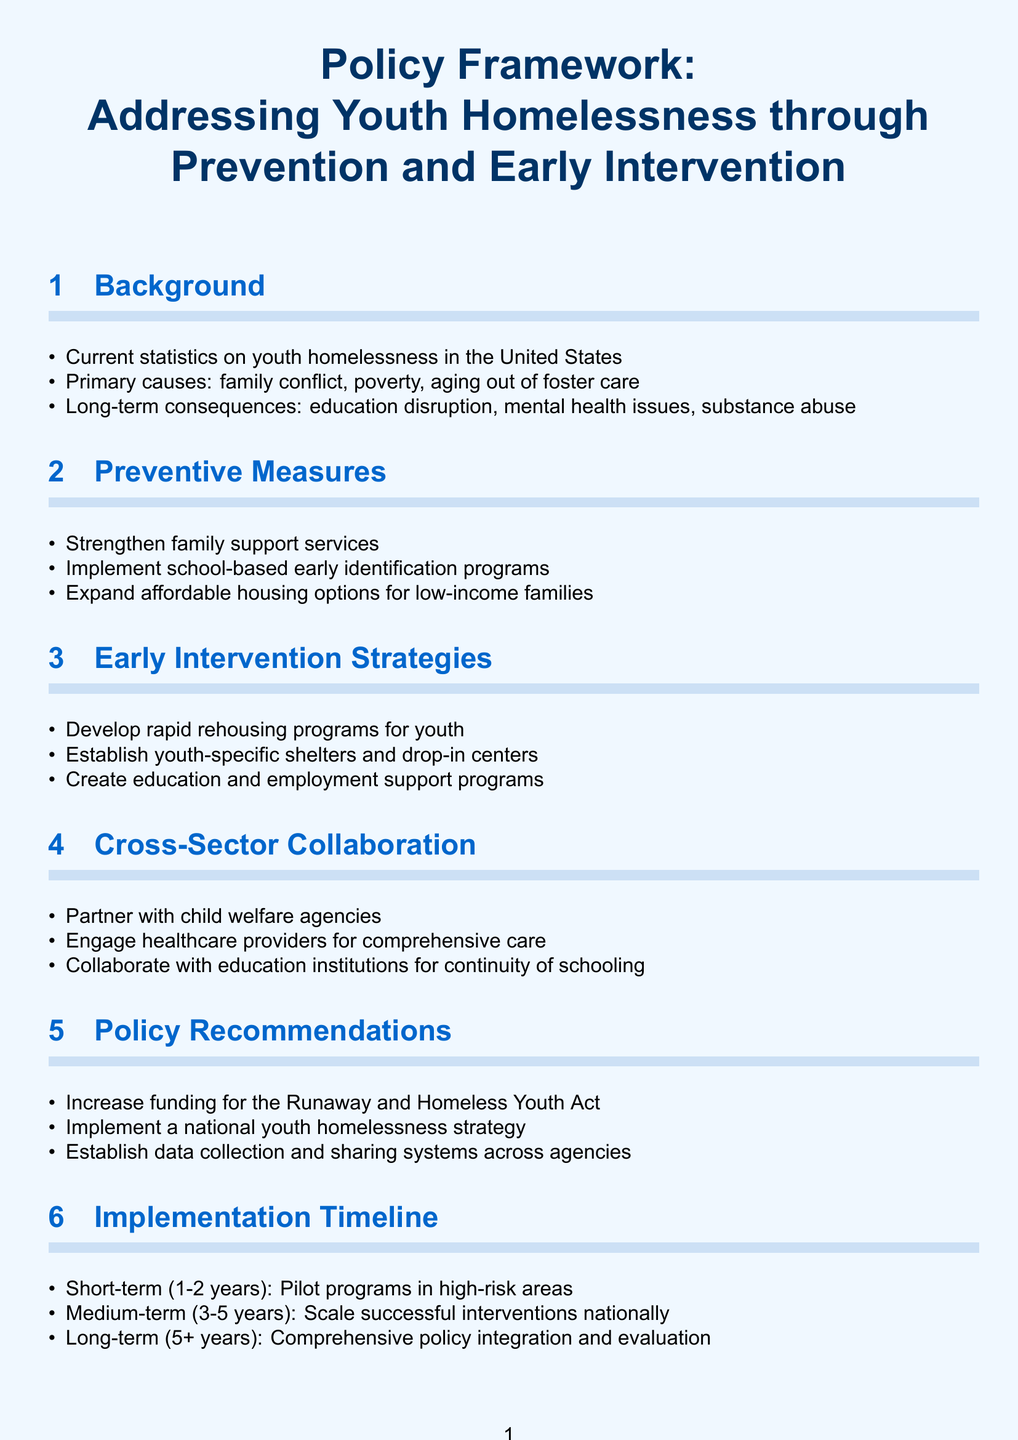What are the primary causes of youth homelessness? The primary causes of youth homelessness listed in the document include family conflict, poverty, and aging out of foster care.
Answer: family conflict, poverty, aging out of foster care What is a short-term goal in the implementation timeline? The short-term goal in the implementation timeline includes pilot programs in high-risk areas within 1-2 years.
Answer: Pilot programs in high-risk areas What is one of the preventive measures suggested? One of the preventive measures outlined in the document is to strengthen family support services.
Answer: Strengthen family support services What type of programs does the document propose to develop for youth? The document proposes to develop rapid rehousing programs specifically for youth as part of early intervention strategies.
Answer: Rapid rehousing programs for youth What is the focus of the cross-sector collaboration section? The focus of the cross-sector collaboration section is to engage various stakeholders, such as child welfare agencies and education institutions, to work together for youth homelessness solutions.
Answer: Partner with child welfare agencies, engage healthcare providers, collaborate with education institutions How long is the medium-term implementation phase according to the timeline? The medium-term implementation phase is defined as 3-5 years in the timeline.
Answer: 3-5 years 